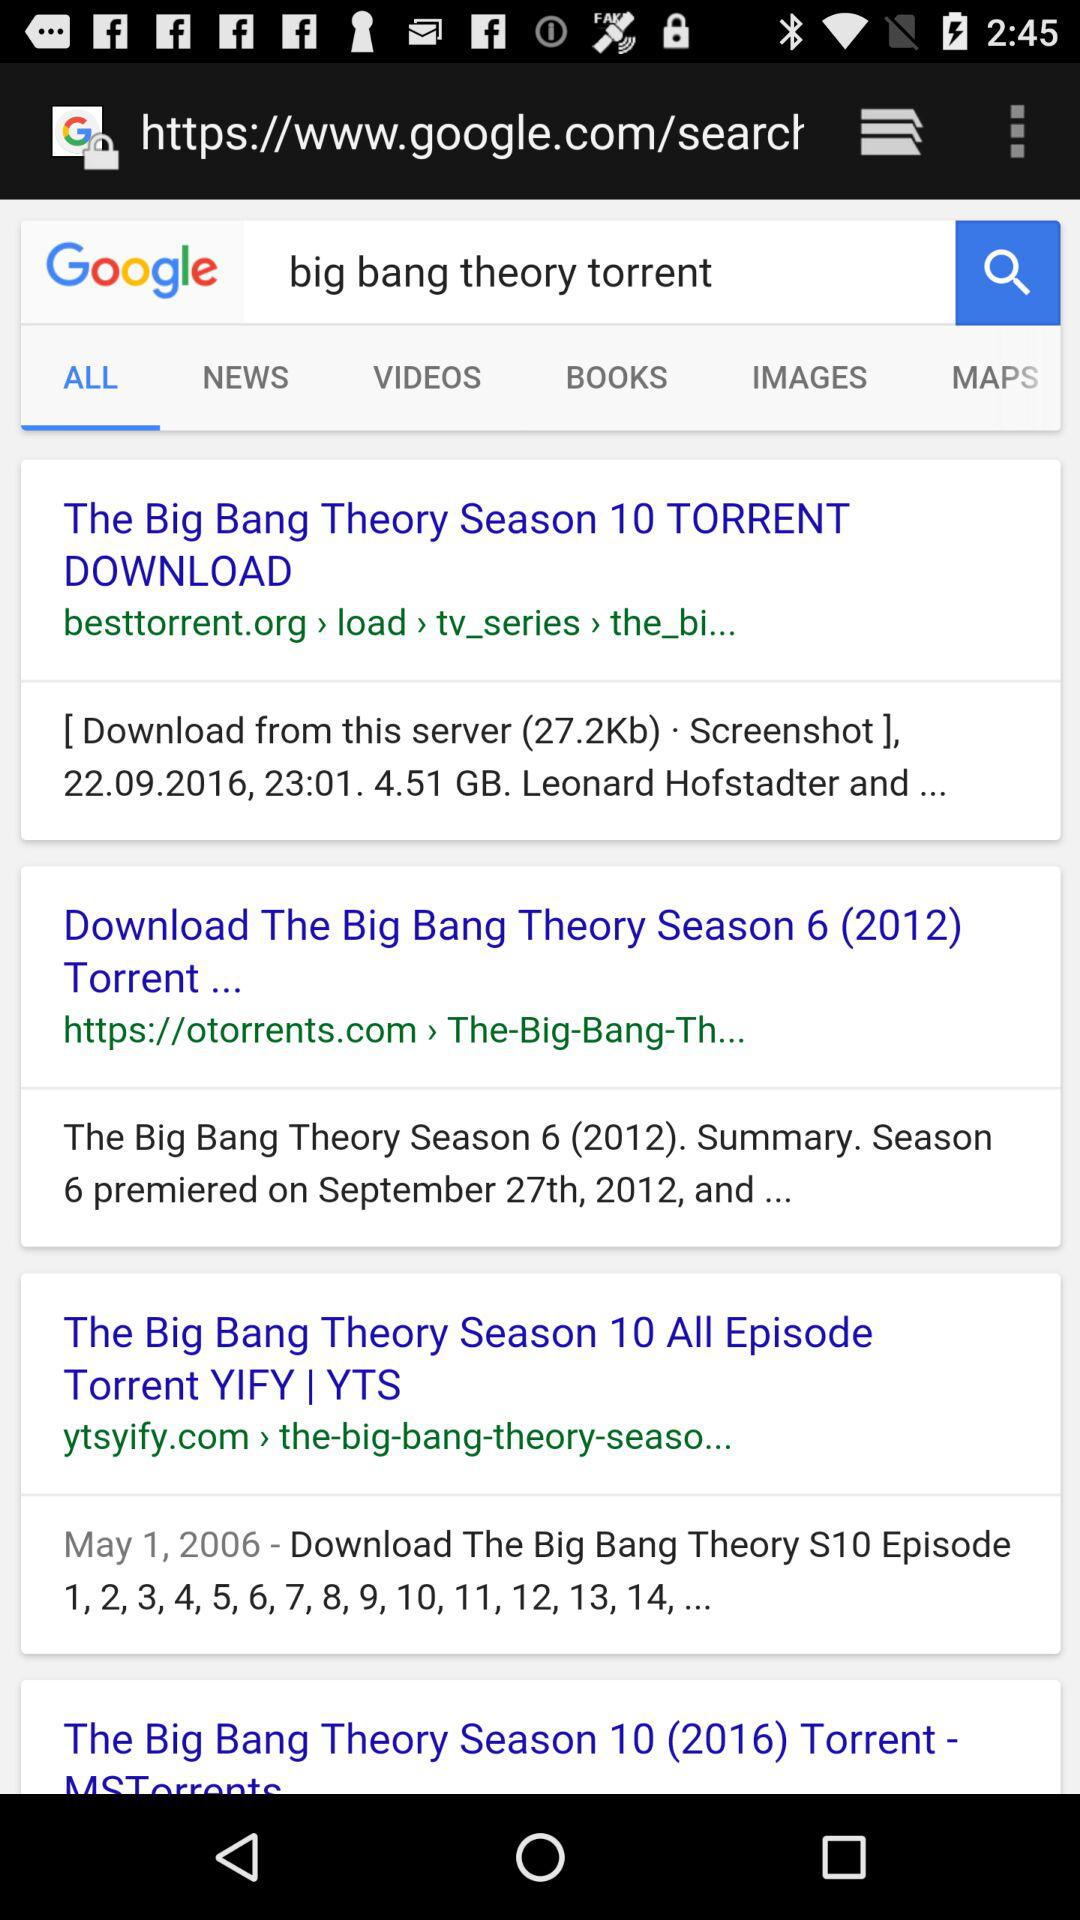What is the name of the application?
When the provided information is insufficient, respond with <no answer>. <no answer> 